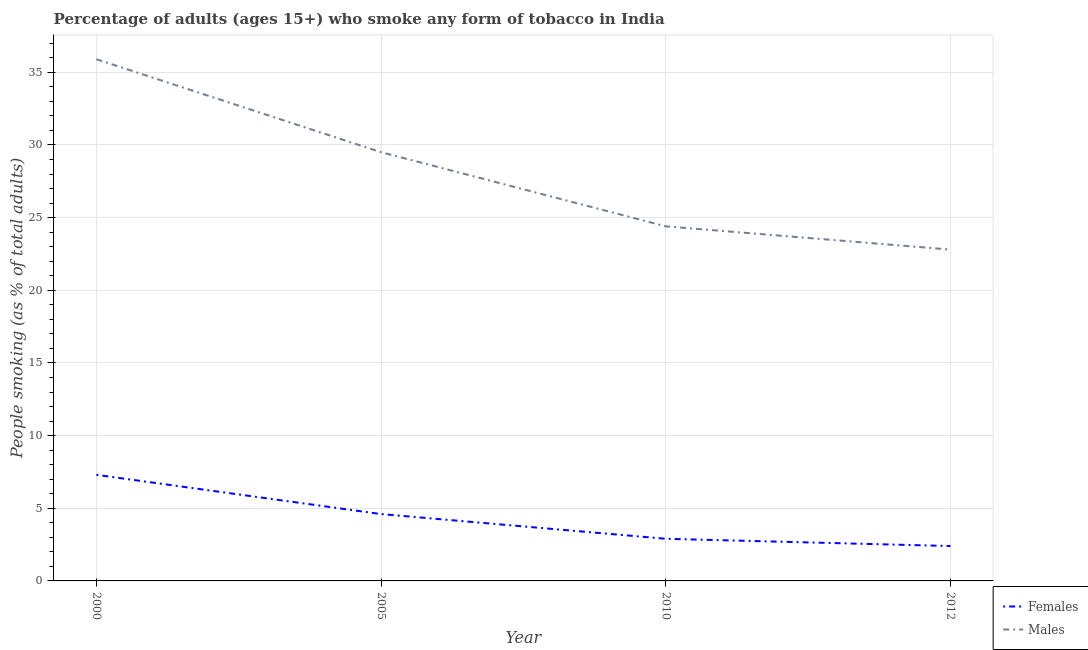How many different coloured lines are there?
Give a very brief answer. 2. What is the percentage of females who smoke in 2010?
Make the answer very short. 2.9. Across all years, what is the maximum percentage of males who smoke?
Provide a succinct answer. 35.9. Across all years, what is the minimum percentage of females who smoke?
Ensure brevity in your answer.  2.4. In which year was the percentage of females who smoke minimum?
Your answer should be compact. 2012. What is the total percentage of females who smoke in the graph?
Your answer should be compact. 17.2. What is the difference between the percentage of females who smoke in 2005 and the percentage of males who smoke in 2000?
Ensure brevity in your answer.  -31.3. What is the average percentage of females who smoke per year?
Keep it short and to the point. 4.3. In the year 2012, what is the difference between the percentage of females who smoke and percentage of males who smoke?
Give a very brief answer. -20.4. What is the ratio of the percentage of males who smoke in 2005 to that in 2012?
Ensure brevity in your answer.  1.29. Is the percentage of females who smoke in 2000 less than that in 2010?
Give a very brief answer. No. What is the difference between the highest and the second highest percentage of males who smoke?
Ensure brevity in your answer.  6.4. In how many years, is the percentage of females who smoke greater than the average percentage of females who smoke taken over all years?
Give a very brief answer. 2. Is the sum of the percentage of females who smoke in 2005 and 2010 greater than the maximum percentage of males who smoke across all years?
Provide a short and direct response. No. Is the percentage of males who smoke strictly greater than the percentage of females who smoke over the years?
Offer a very short reply. Yes. How many lines are there?
Keep it short and to the point. 2. How many years are there in the graph?
Keep it short and to the point. 4. Does the graph contain any zero values?
Your response must be concise. No. How many legend labels are there?
Make the answer very short. 2. What is the title of the graph?
Your response must be concise. Percentage of adults (ages 15+) who smoke any form of tobacco in India. What is the label or title of the X-axis?
Make the answer very short. Year. What is the label or title of the Y-axis?
Keep it short and to the point. People smoking (as % of total adults). What is the People smoking (as % of total adults) in Males in 2000?
Your response must be concise. 35.9. What is the People smoking (as % of total adults) of Females in 2005?
Offer a terse response. 4.6. What is the People smoking (as % of total adults) in Males in 2005?
Provide a succinct answer. 29.5. What is the People smoking (as % of total adults) of Males in 2010?
Make the answer very short. 24.4. What is the People smoking (as % of total adults) of Males in 2012?
Provide a short and direct response. 22.8. Across all years, what is the maximum People smoking (as % of total adults) in Females?
Offer a very short reply. 7.3. Across all years, what is the maximum People smoking (as % of total adults) of Males?
Give a very brief answer. 35.9. Across all years, what is the minimum People smoking (as % of total adults) in Females?
Your response must be concise. 2.4. Across all years, what is the minimum People smoking (as % of total adults) of Males?
Provide a short and direct response. 22.8. What is the total People smoking (as % of total adults) of Females in the graph?
Keep it short and to the point. 17.2. What is the total People smoking (as % of total adults) of Males in the graph?
Provide a short and direct response. 112.6. What is the difference between the People smoking (as % of total adults) of Males in 2000 and that in 2005?
Your answer should be compact. 6.4. What is the difference between the People smoking (as % of total adults) in Males in 2000 and that in 2010?
Your response must be concise. 11.5. What is the difference between the People smoking (as % of total adults) in Males in 2000 and that in 2012?
Give a very brief answer. 13.1. What is the difference between the People smoking (as % of total adults) of Females in 2010 and that in 2012?
Offer a very short reply. 0.5. What is the difference between the People smoking (as % of total adults) in Males in 2010 and that in 2012?
Your answer should be compact. 1.6. What is the difference between the People smoking (as % of total adults) in Females in 2000 and the People smoking (as % of total adults) in Males in 2005?
Give a very brief answer. -22.2. What is the difference between the People smoking (as % of total adults) of Females in 2000 and the People smoking (as % of total adults) of Males in 2010?
Offer a terse response. -17.1. What is the difference between the People smoking (as % of total adults) of Females in 2000 and the People smoking (as % of total adults) of Males in 2012?
Ensure brevity in your answer.  -15.5. What is the difference between the People smoking (as % of total adults) of Females in 2005 and the People smoking (as % of total adults) of Males in 2010?
Keep it short and to the point. -19.8. What is the difference between the People smoking (as % of total adults) in Females in 2005 and the People smoking (as % of total adults) in Males in 2012?
Offer a terse response. -18.2. What is the difference between the People smoking (as % of total adults) of Females in 2010 and the People smoking (as % of total adults) of Males in 2012?
Provide a short and direct response. -19.9. What is the average People smoking (as % of total adults) in Males per year?
Provide a succinct answer. 28.15. In the year 2000, what is the difference between the People smoking (as % of total adults) in Females and People smoking (as % of total adults) in Males?
Provide a succinct answer. -28.6. In the year 2005, what is the difference between the People smoking (as % of total adults) of Females and People smoking (as % of total adults) of Males?
Your response must be concise. -24.9. In the year 2010, what is the difference between the People smoking (as % of total adults) of Females and People smoking (as % of total adults) of Males?
Give a very brief answer. -21.5. In the year 2012, what is the difference between the People smoking (as % of total adults) in Females and People smoking (as % of total adults) in Males?
Provide a short and direct response. -20.4. What is the ratio of the People smoking (as % of total adults) in Females in 2000 to that in 2005?
Offer a terse response. 1.59. What is the ratio of the People smoking (as % of total adults) of Males in 2000 to that in 2005?
Offer a terse response. 1.22. What is the ratio of the People smoking (as % of total adults) in Females in 2000 to that in 2010?
Give a very brief answer. 2.52. What is the ratio of the People smoking (as % of total adults) in Males in 2000 to that in 2010?
Make the answer very short. 1.47. What is the ratio of the People smoking (as % of total adults) in Females in 2000 to that in 2012?
Provide a short and direct response. 3.04. What is the ratio of the People smoking (as % of total adults) of Males in 2000 to that in 2012?
Make the answer very short. 1.57. What is the ratio of the People smoking (as % of total adults) in Females in 2005 to that in 2010?
Keep it short and to the point. 1.59. What is the ratio of the People smoking (as % of total adults) of Males in 2005 to that in 2010?
Make the answer very short. 1.21. What is the ratio of the People smoking (as % of total adults) in Females in 2005 to that in 2012?
Offer a very short reply. 1.92. What is the ratio of the People smoking (as % of total adults) of Males in 2005 to that in 2012?
Offer a terse response. 1.29. What is the ratio of the People smoking (as % of total adults) of Females in 2010 to that in 2012?
Provide a short and direct response. 1.21. What is the ratio of the People smoking (as % of total adults) of Males in 2010 to that in 2012?
Offer a very short reply. 1.07. What is the difference between the highest and the second highest People smoking (as % of total adults) in Females?
Keep it short and to the point. 2.7. What is the difference between the highest and the second highest People smoking (as % of total adults) of Males?
Make the answer very short. 6.4. 